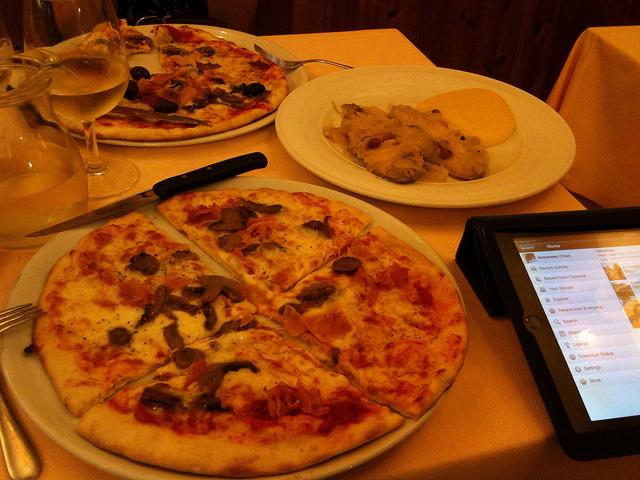What tool is shown?
Keep it brief. Knife. What kind of toppings are on the pizza?
Short answer required. Mushrooms. Is the tablet on?
Quick response, please. Yes. How many forks are in the picture?
Be succinct. 2. 